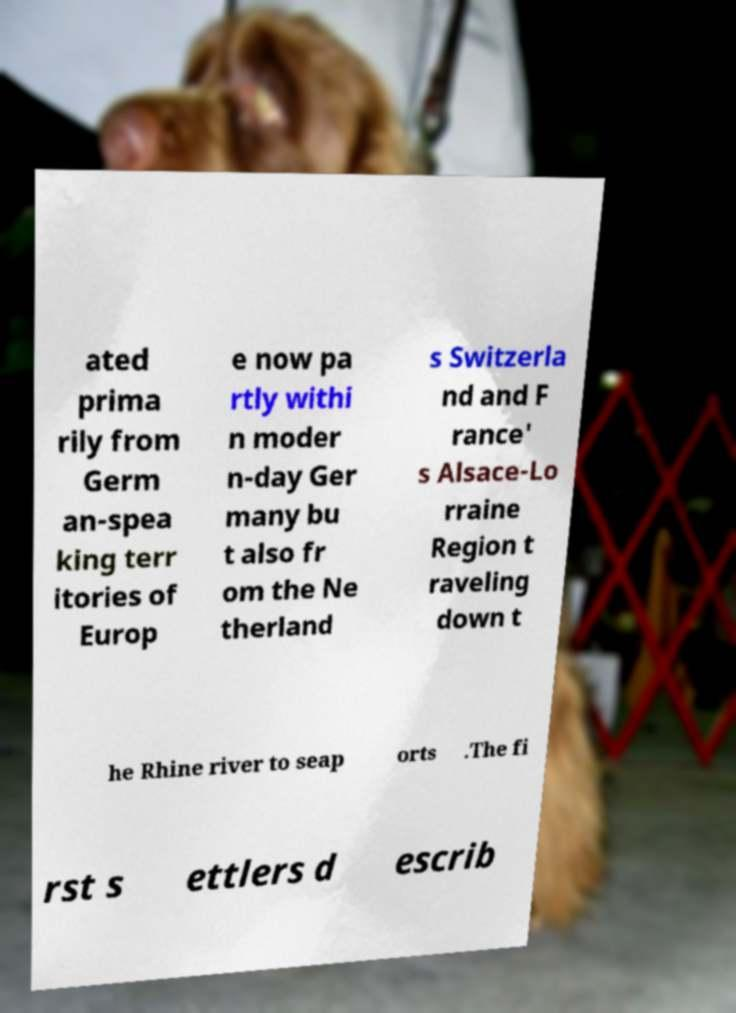For documentation purposes, I need the text within this image transcribed. Could you provide that? ated prima rily from Germ an-spea king terr itories of Europ e now pa rtly withi n moder n-day Ger many bu t also fr om the Ne therland s Switzerla nd and F rance' s Alsace-Lo rraine Region t raveling down t he Rhine river to seap orts .The fi rst s ettlers d escrib 